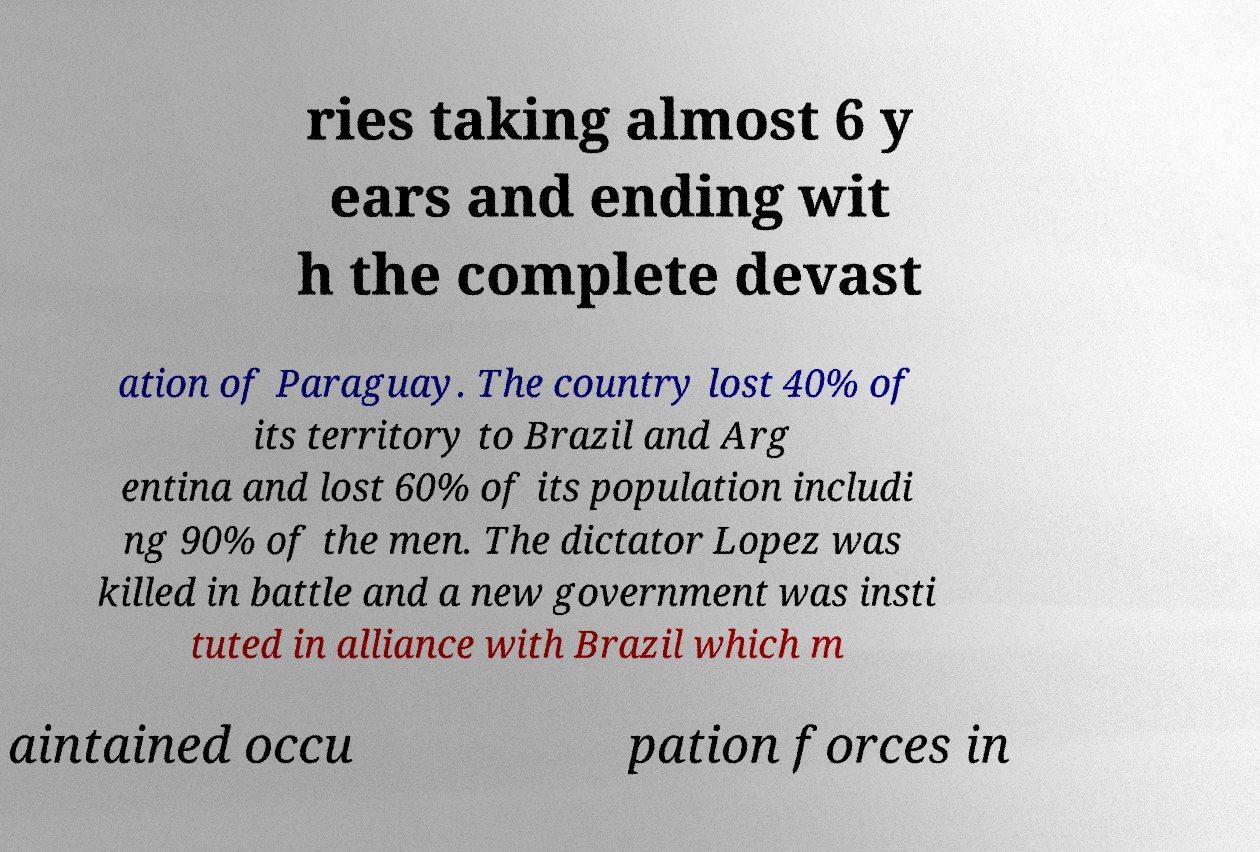Please identify and transcribe the text found in this image. ries taking almost 6 y ears and ending wit h the complete devast ation of Paraguay. The country lost 40% of its territory to Brazil and Arg entina and lost 60% of its population includi ng 90% of the men. The dictator Lopez was killed in battle and a new government was insti tuted in alliance with Brazil which m aintained occu pation forces in 